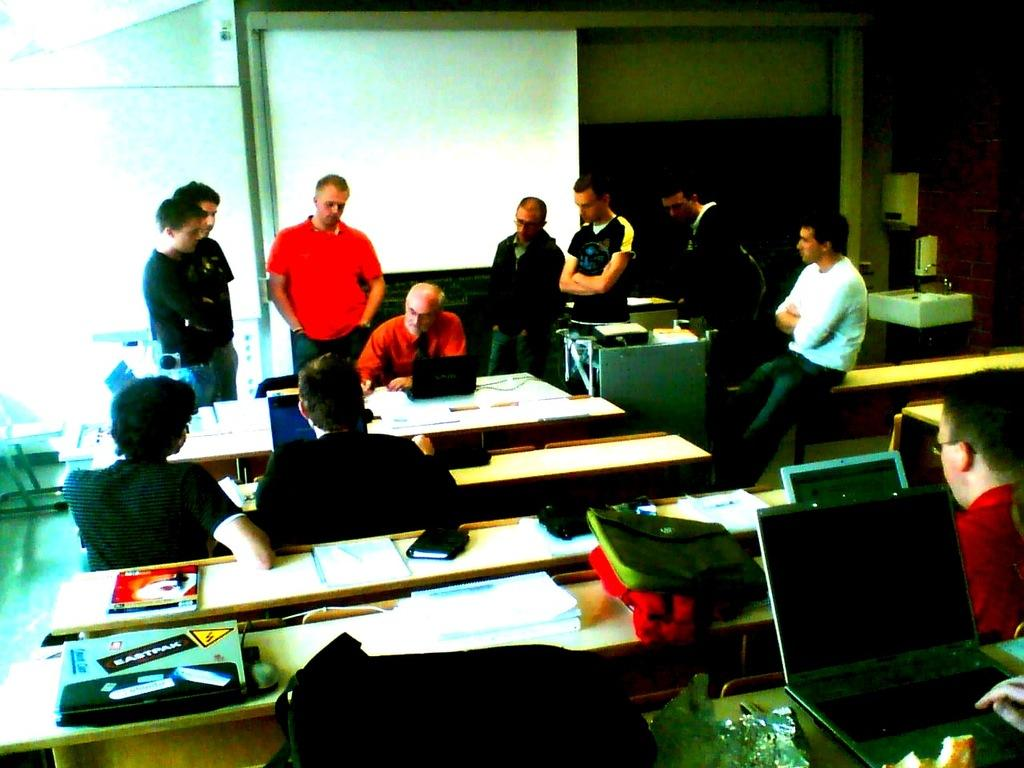What are the persons in the image doing? Some persons are sitting on chairs, while others are standing. What objects can be seen on the table? There are laptops, books, and papers on the table. What can be seen in the background of the image? There is a wall and a screen in the background. What part of the room is visible? The floor is visible. How many dogs are present in the image? There are no dogs visible in the image. Can you tell me the name of the friend who is standing next to the person with the red shirt? There is no information about friends or names of individuals in the image. 